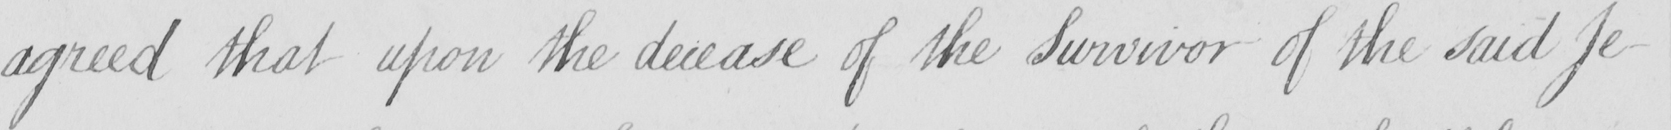What does this handwritten line say? agreed that upon the decease of the Survivor of the said Je- 